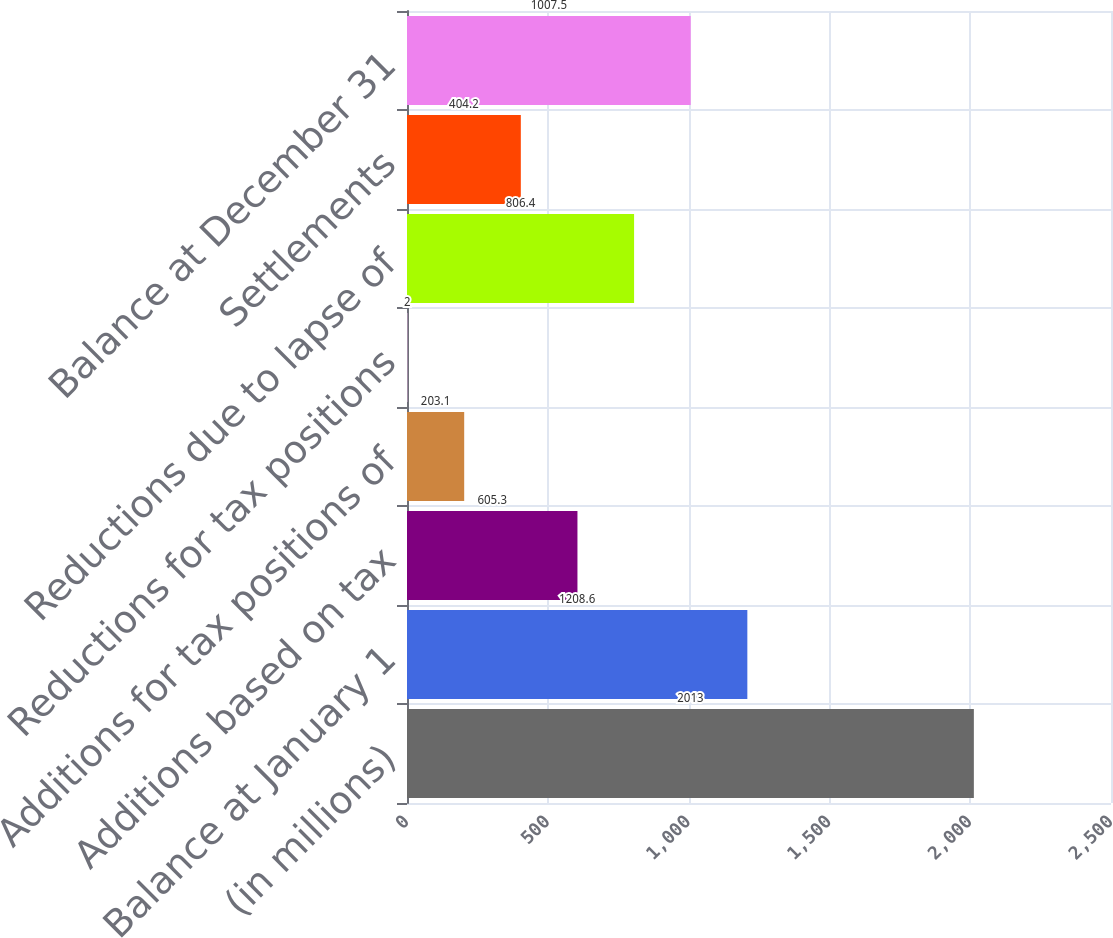Convert chart to OTSL. <chart><loc_0><loc_0><loc_500><loc_500><bar_chart><fcel>(in millions)<fcel>Balance at January 1<fcel>Additions based on tax<fcel>Additions for tax positions of<fcel>Reductions for tax positions<fcel>Reductions due to lapse of<fcel>Settlements<fcel>Balance at December 31<nl><fcel>2013<fcel>1208.6<fcel>605.3<fcel>203.1<fcel>2<fcel>806.4<fcel>404.2<fcel>1007.5<nl></chart> 